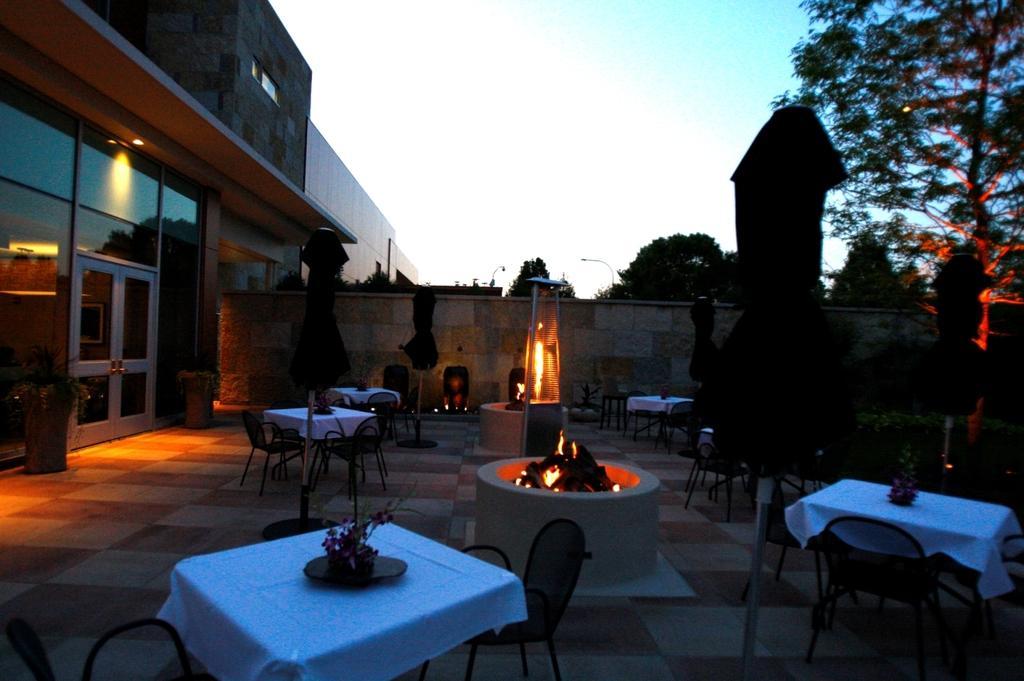Please provide a concise description of this image. This picture might be taken in a restaurant. In this image, on the right side, we can see some tables and chairs, trees. On that table, we can see a white color cloth and flower pot, plant. On the left side, we can see some tables and chairs. On that table, we can see a white colored cloth. On the left side, we can also see a building, glass window, door, flower pot, plant. In the middle of the image, we can see a water well, in the water well, we can see a fire. In the background, we can see a wall, street light. At the top, we can see a sky. 